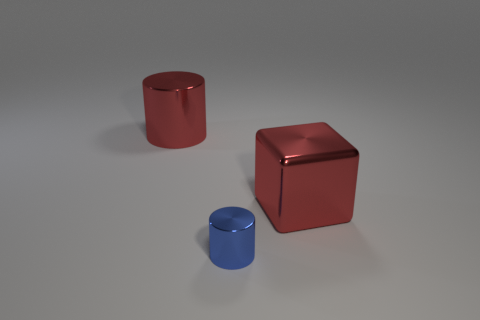Add 1 big yellow metal objects. How many objects exist? 4 Subtract all red cylinders. How many cylinders are left? 1 Subtract all cubes. How many objects are left? 2 Subtract 0 green blocks. How many objects are left? 3 Subtract all green blocks. Subtract all green cylinders. How many blocks are left? 1 Subtract all blue cylinders. Subtract all small red matte cubes. How many objects are left? 2 Add 3 shiny things. How many shiny things are left? 6 Add 1 large spheres. How many large spheres exist? 1 